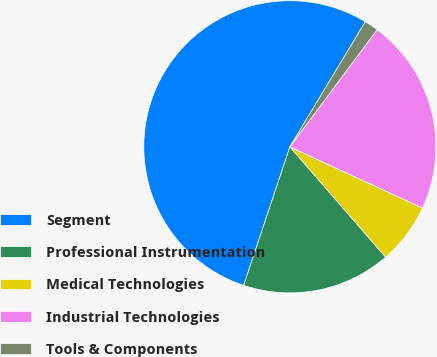<chart> <loc_0><loc_0><loc_500><loc_500><pie_chart><fcel>Segment<fcel>Professional Instrumentation<fcel>Medical Technologies<fcel>Industrial Technologies<fcel>Tools & Components<nl><fcel>53.52%<fcel>16.5%<fcel>6.74%<fcel>21.7%<fcel>1.55%<nl></chart> 